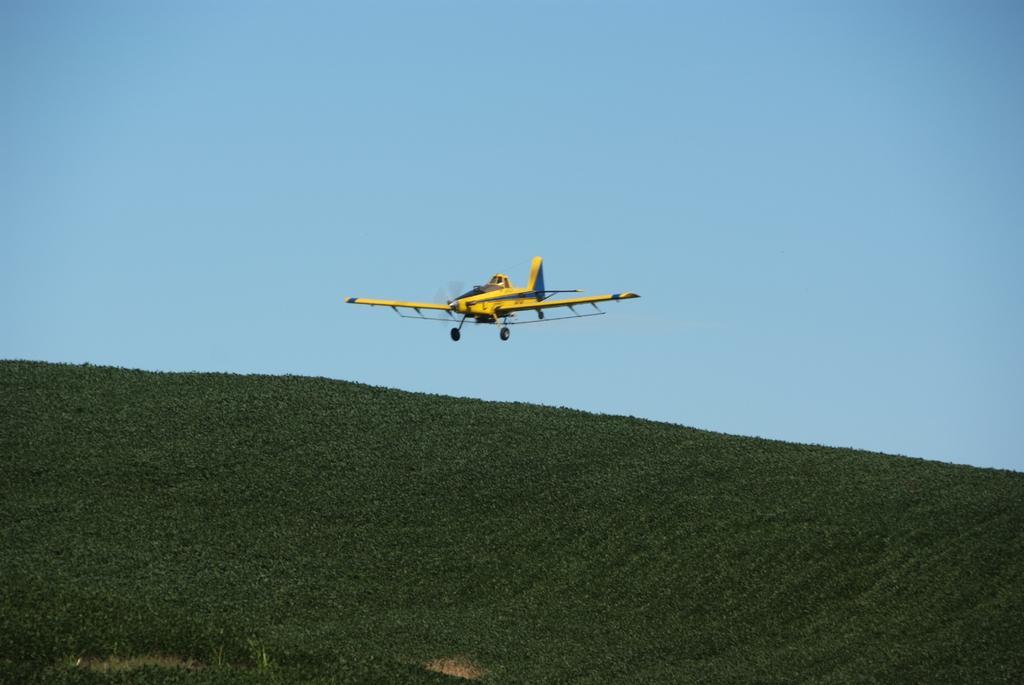Could you give a brief overview of what you see in this image? In this picture there is greenery at the bottom side of the image and there is an air craft in the center of the image. 